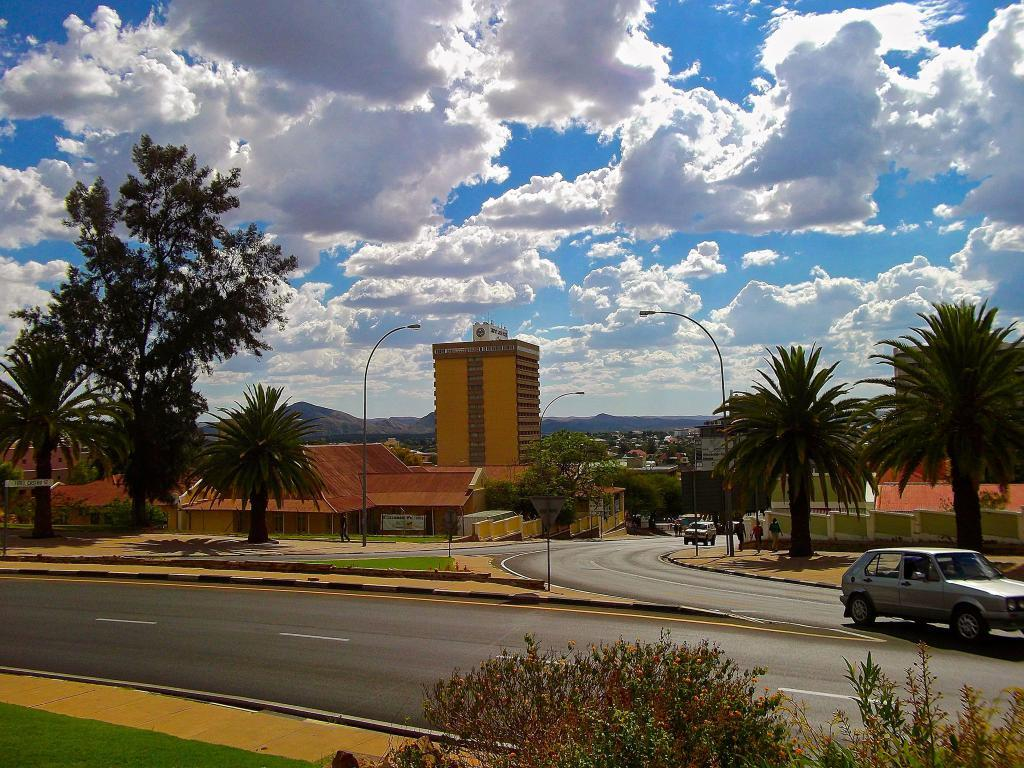What can be seen on the road in the image? There are vehicles on the road in the image. What structures are present along the road? There are light poles in the image. What type of man-made structures can be seen in the image? There are buildings in the image. Are there any living beings visible in the image? Yes, there are people in the image. What natural feature is visible in the background of the image? There are mountains in the image. What else can be seen in the image besides the vehicles, light poles, buildings, people, and mountains? There are objects in the image. What is visible in the sky in the background of the image? The sky is visible in the background of the image, and clouds are present in the sky. Can you tell me how many elbows are visible in the image? There are no elbows visible in the image. What type of rail is present in the image? There is no rail present in the image. 